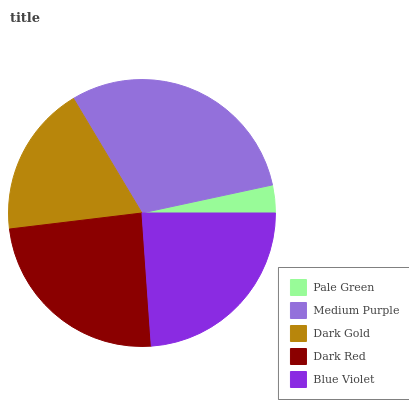Is Pale Green the minimum?
Answer yes or no. Yes. Is Medium Purple the maximum?
Answer yes or no. Yes. Is Dark Gold the minimum?
Answer yes or no. No. Is Dark Gold the maximum?
Answer yes or no. No. Is Medium Purple greater than Dark Gold?
Answer yes or no. Yes. Is Dark Gold less than Medium Purple?
Answer yes or no. Yes. Is Dark Gold greater than Medium Purple?
Answer yes or no. No. Is Medium Purple less than Dark Gold?
Answer yes or no. No. Is Blue Violet the high median?
Answer yes or no. Yes. Is Blue Violet the low median?
Answer yes or no. Yes. Is Dark Gold the high median?
Answer yes or no. No. Is Pale Green the low median?
Answer yes or no. No. 